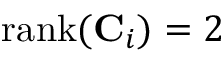<formula> <loc_0><loc_0><loc_500><loc_500>{ r a n k } ( C _ { i } ) = 2</formula> 